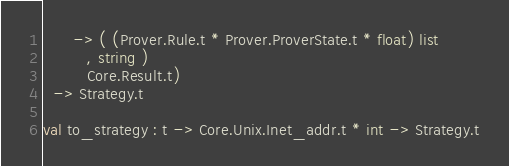Convert code to text. <code><loc_0><loc_0><loc_500><loc_500><_OCaml_>      -> ( (Prover.Rule.t * Prover.ProverState.t * float) list
         , string )
         Core.Result.t)
  -> Strategy.t

val to_strategy : t -> Core.Unix.Inet_addr.t * int -> Strategy.t
</code> 